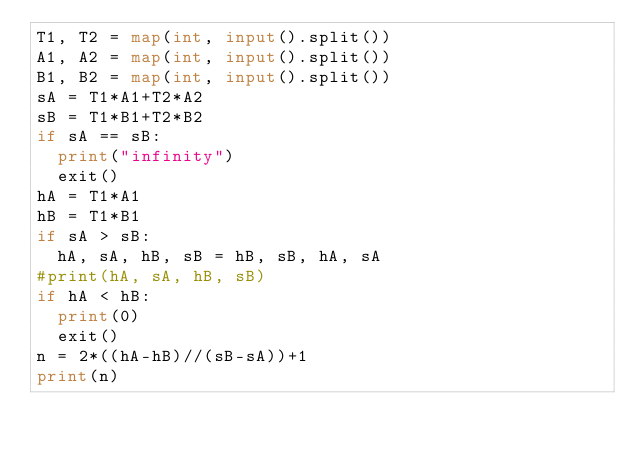Convert code to text. <code><loc_0><loc_0><loc_500><loc_500><_Python_>T1, T2 = map(int, input().split())
A1, A2 = map(int, input().split())
B1, B2 = map(int, input().split())
sA = T1*A1+T2*A2
sB = T1*B1+T2*B2
if sA == sB:
  print("infinity")
  exit()
hA = T1*A1
hB = T1*B1
if sA > sB:
  hA, sA, hB, sB = hB, sB, hA, sA
#print(hA, sA, hB, sB)
if hA < hB:
  print(0)
  exit()
n = 2*((hA-hB)//(sB-sA))+1
print(n)
</code> 